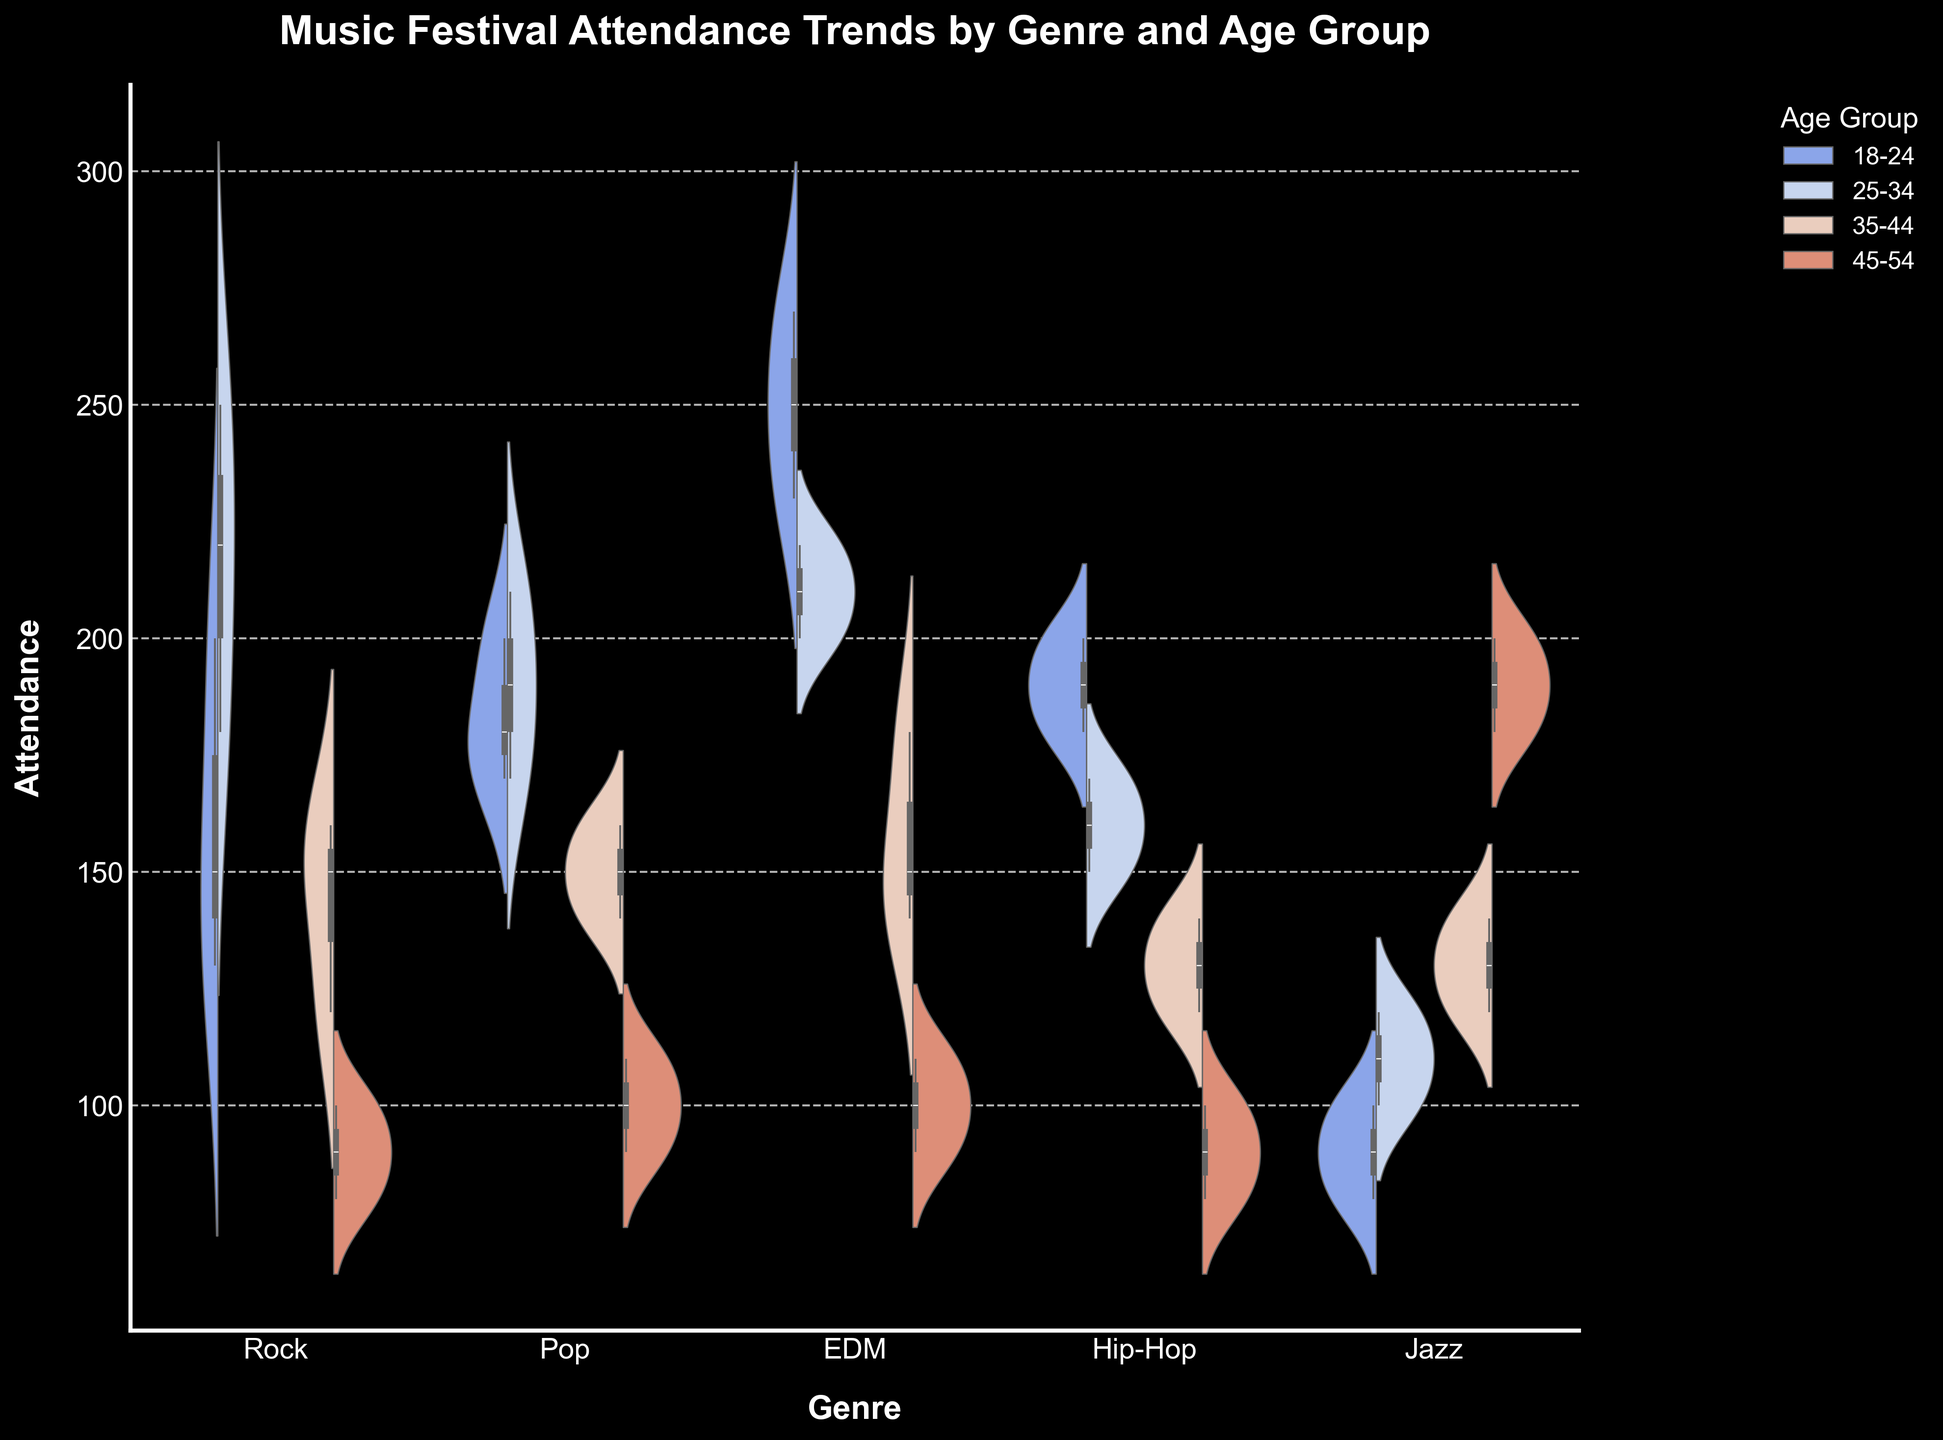What is the title of the figure? The title of the figure is shown at the top of the chart. It reads "Music Festival Attendance Trends by Genre and Age Group".
Answer: Music Festival Attendance Trends by Genre and Age Group Which genre has the highest attendance in the 18-24 age group? From the figure, we can see that the highest attendance for the 18-24 age group is represented by the tallest overlayed box in the violin plot for the EDM genre.
Answer: EDM In the rock genre, what is the attendance range for the 25-34 age group? The figure shows a box plot overlayed within the violin plot for each genre. For the rock genre, the attendance range for the 25-34 age group is shown by the whiskers of the box plot, which span from 180 to 250.
Answer: 180 to 250 Which age group has the widest attendance distribution in the jazz genre? For the jazz genre, the violin plot that is widest indicates the age group with the widest attendance distribution. This is the 45-54 age group.
Answer: 45-54 How does the attendance distribution for the 35-44 age group compare between pop and hip-hop genres? In the figure, comparing the violin plots for the 35-44 age group in both the pop and hip-hop genres, the pop genre has a wider and higher distribution indicating generally higher attendance compared to hip-hop.
Answer: Pop has a higher attendance What is the median attendance for the 18-24 age group in the hip-hop genre? The median attendance is indicated by the line inside the box plot within the violin plot. For the 18-24 age group in the hip-hop genre, the median line is at approximately 190.
Answer: 190 Which genre shows the smallest variance in attendance for the 45-54 age group? The smallest variance is represented by the most narrow and condensed violin plot segment for the 45-54 age group across the genres. This is observed in the hip-hop genre.
Answer: Hip-Hop What is the difference between the median attendance of the 18-24 and 35-44 age groups in the EDM genre? The median attendance for the 18-24 age group in EDM is around 250, and for the 35-44 age group, it is around 150. The difference is 250 - 150.
Answer: 100 Which genre has the most balanced attendance distribution between different age groups? A balanced attendance distribution would show violin plots with relatively even widths across all age groups. From the figure, pop shows a relatively balanced distribution among the age groups.
Answer: Pop 